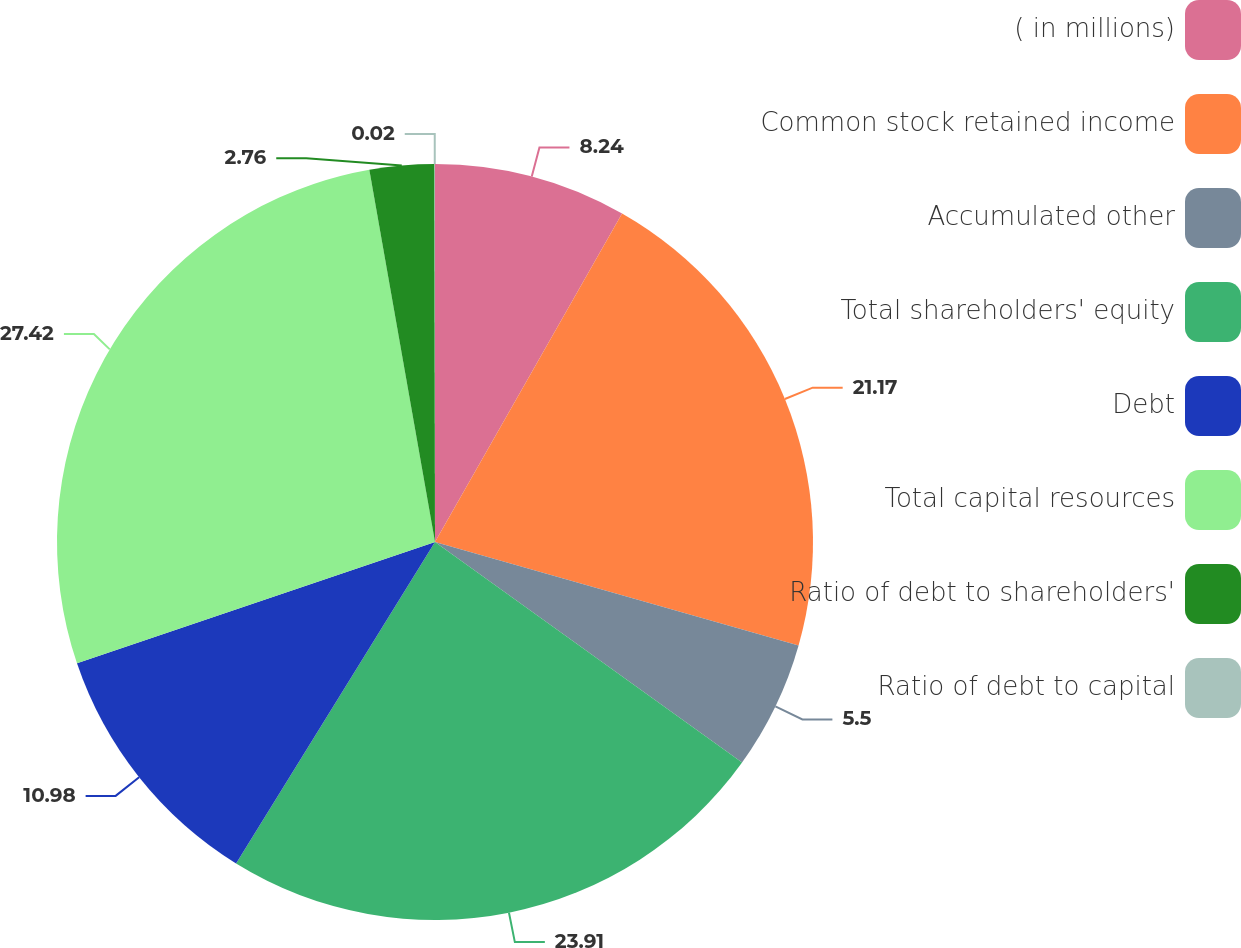<chart> <loc_0><loc_0><loc_500><loc_500><pie_chart><fcel>( in millions)<fcel>Common stock retained income<fcel>Accumulated other<fcel>Total shareholders' equity<fcel>Debt<fcel>Total capital resources<fcel>Ratio of debt to shareholders'<fcel>Ratio of debt to capital<nl><fcel>8.24%<fcel>21.17%<fcel>5.5%<fcel>23.91%<fcel>10.98%<fcel>27.42%<fcel>2.76%<fcel>0.02%<nl></chart> 